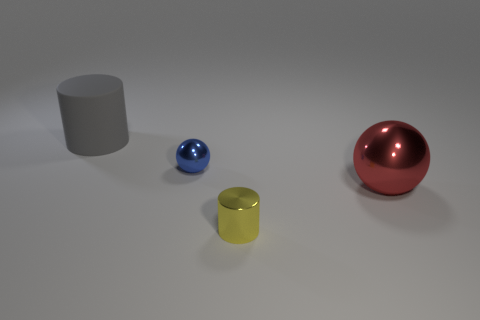Add 4 small spheres. How many objects exist? 8 Add 4 rubber cylinders. How many rubber cylinders are left? 5 Add 3 gray matte cylinders. How many gray matte cylinders exist? 4 Subtract 1 gray cylinders. How many objects are left? 3 Subtract all tiny yellow things. Subtract all big rubber objects. How many objects are left? 2 